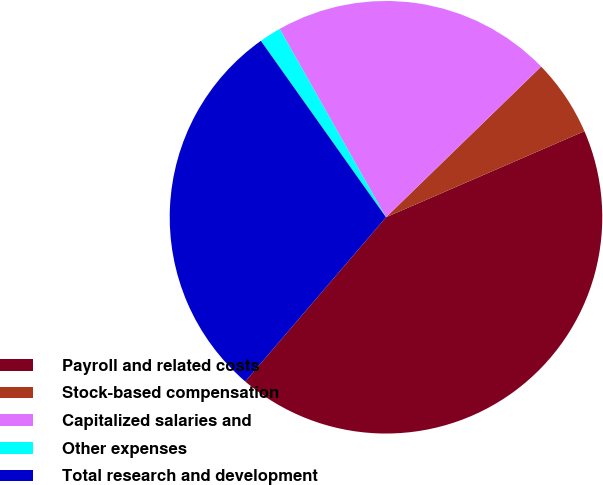Convert chart to OTSL. <chart><loc_0><loc_0><loc_500><loc_500><pie_chart><fcel>Payroll and related costs<fcel>Stock-based compensation<fcel>Capitalized salaries and<fcel>Other expenses<fcel>Total research and development<nl><fcel>42.79%<fcel>5.75%<fcel>20.91%<fcel>1.64%<fcel>28.9%<nl></chart> 